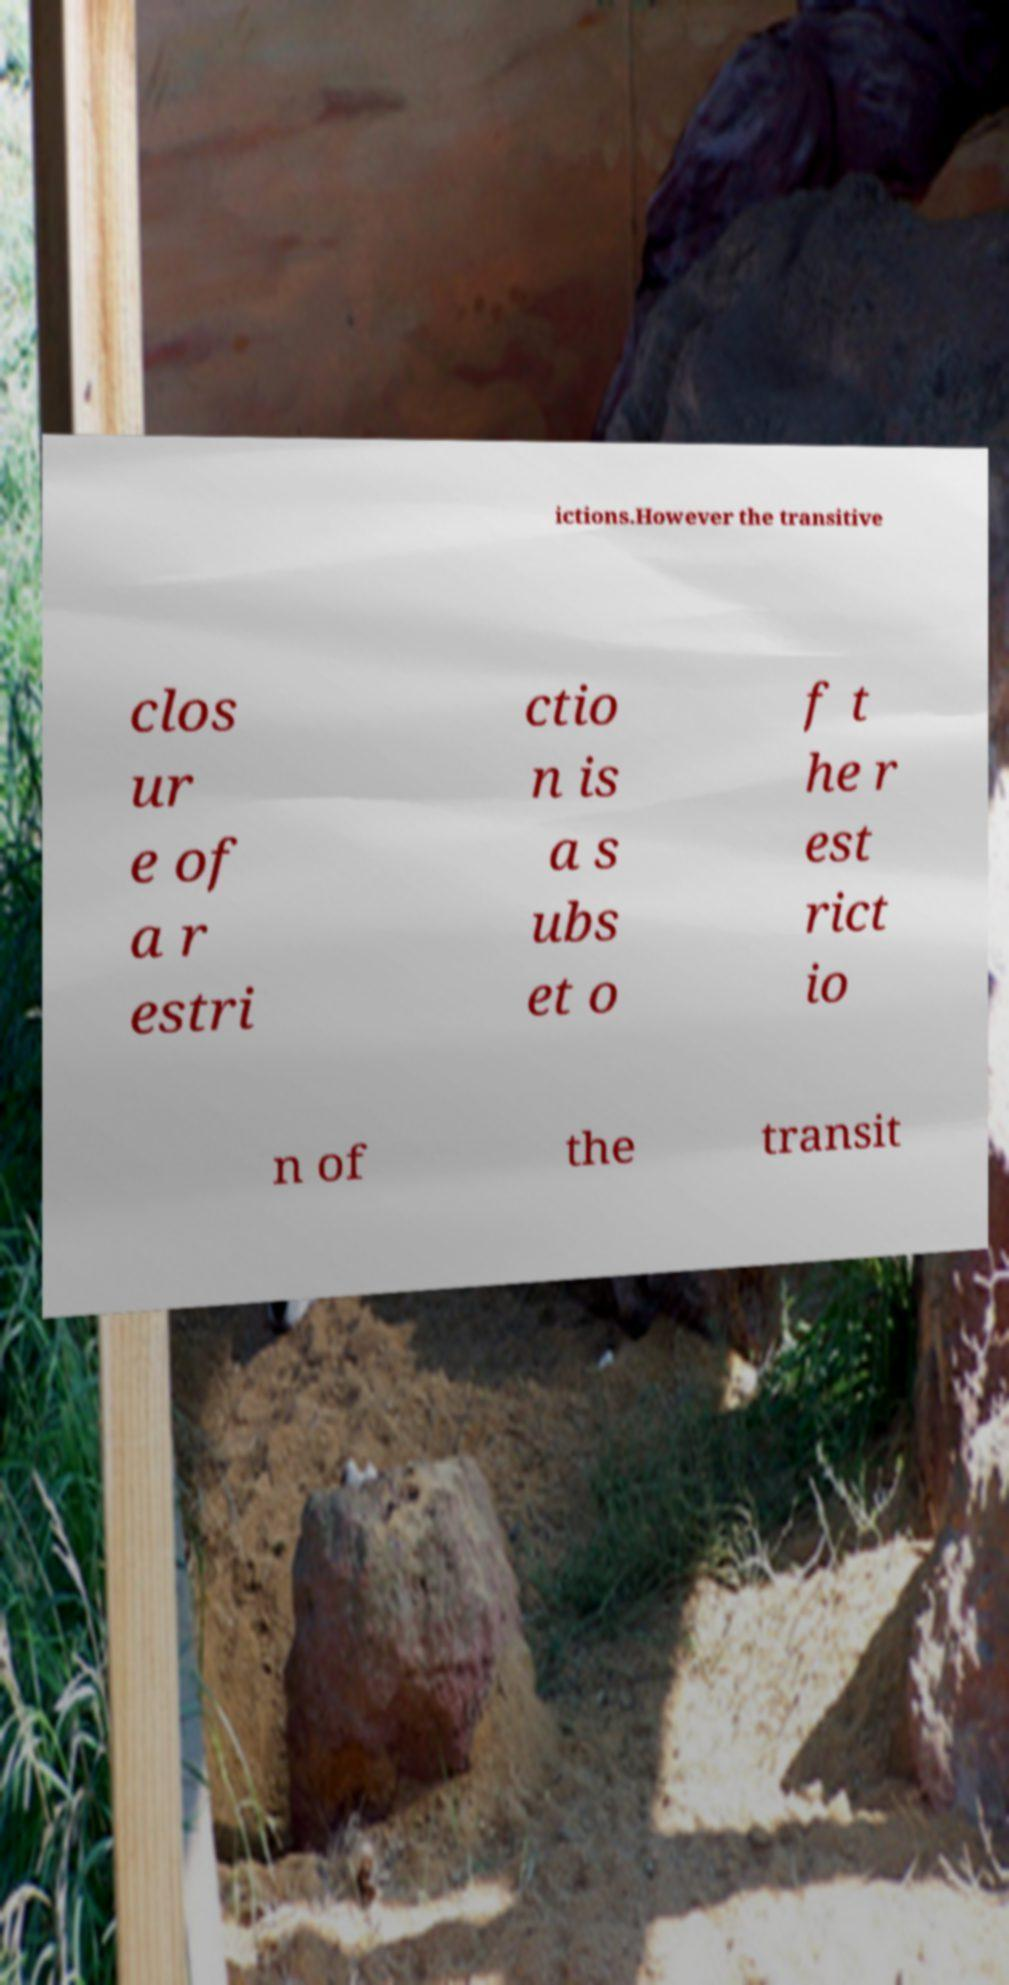Please read and relay the text visible in this image. What does it say? ictions.However the transitive clos ur e of a r estri ctio n is a s ubs et o f t he r est rict io n of the transit 